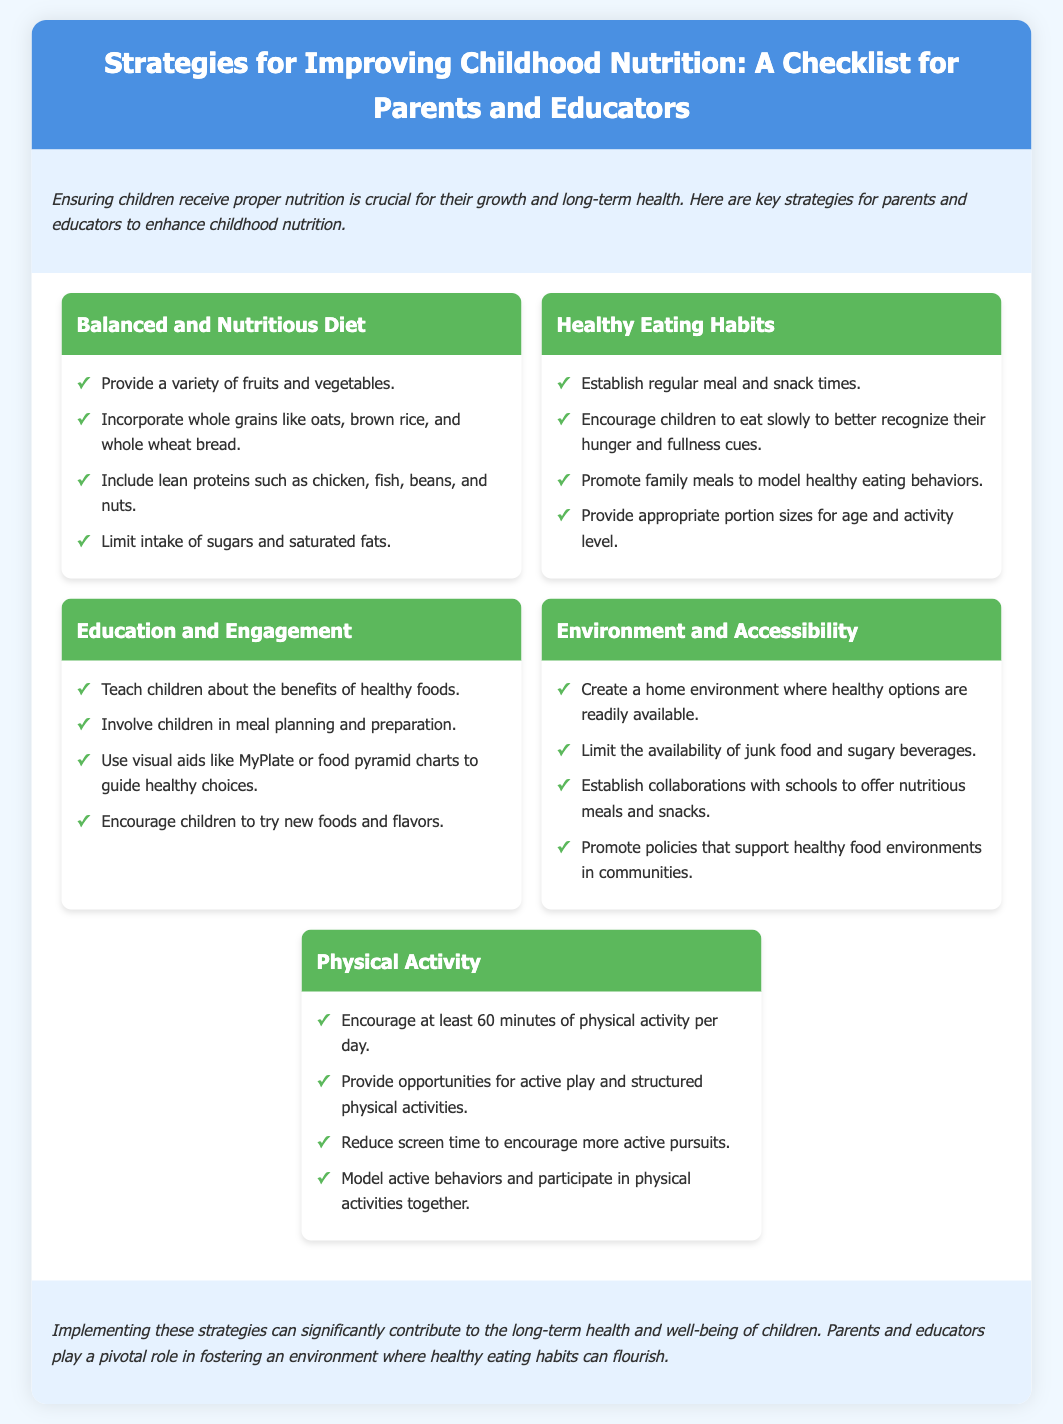what are two key components of a balanced and nutritious diet? The document lists specific items under the "Balanced and Nutritious Diet" strategy, which include fruits, vegetables, grains, and proteins.
Answer: fruits and vegetables what is the recommended daily amount of physical activity for children? According to the "Physical Activity" strategy, children should engage in a specific amount of daily activity.
Answer: 60 minutes which habit should parents encourage to promote healthy eating? The "Healthy Eating Habits" section includes suggestions about meal timings and eating behaviors.
Answer: family meals what is one way to create a healthy food environment at home? The document suggests specific strategies under "Environment and Accessibility" for promoting healthy food options at home.
Answer: limit junk food how can educators engage children in learning about nutrition? The "Education and Engagement" strategy includes several methods for helping children understand healthy eating.
Answer: involve children in meal planning what is a reason to promote physical activity among children? The "Physical Activity" section highlights benefits of active behaviors for health improvement, including reducing sedentary time.
Answer: health improvement name one food group to include in a balanced diet. The strategies list specific food groups that should be part of a balanced diet.
Answer: lean proteins what should be the focus of meal times to encourage healthy habits? The "Healthy Eating Habits" section mentions the importance of specific meal-related practices.
Answer: regular meal and snack times 